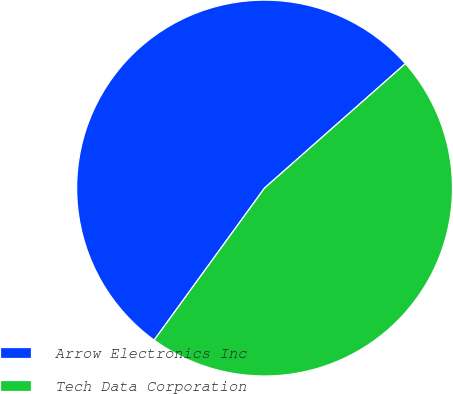Convert chart. <chart><loc_0><loc_0><loc_500><loc_500><pie_chart><fcel>Arrow Electronics Inc<fcel>Tech Data Corporation<nl><fcel>53.49%<fcel>46.51%<nl></chart> 